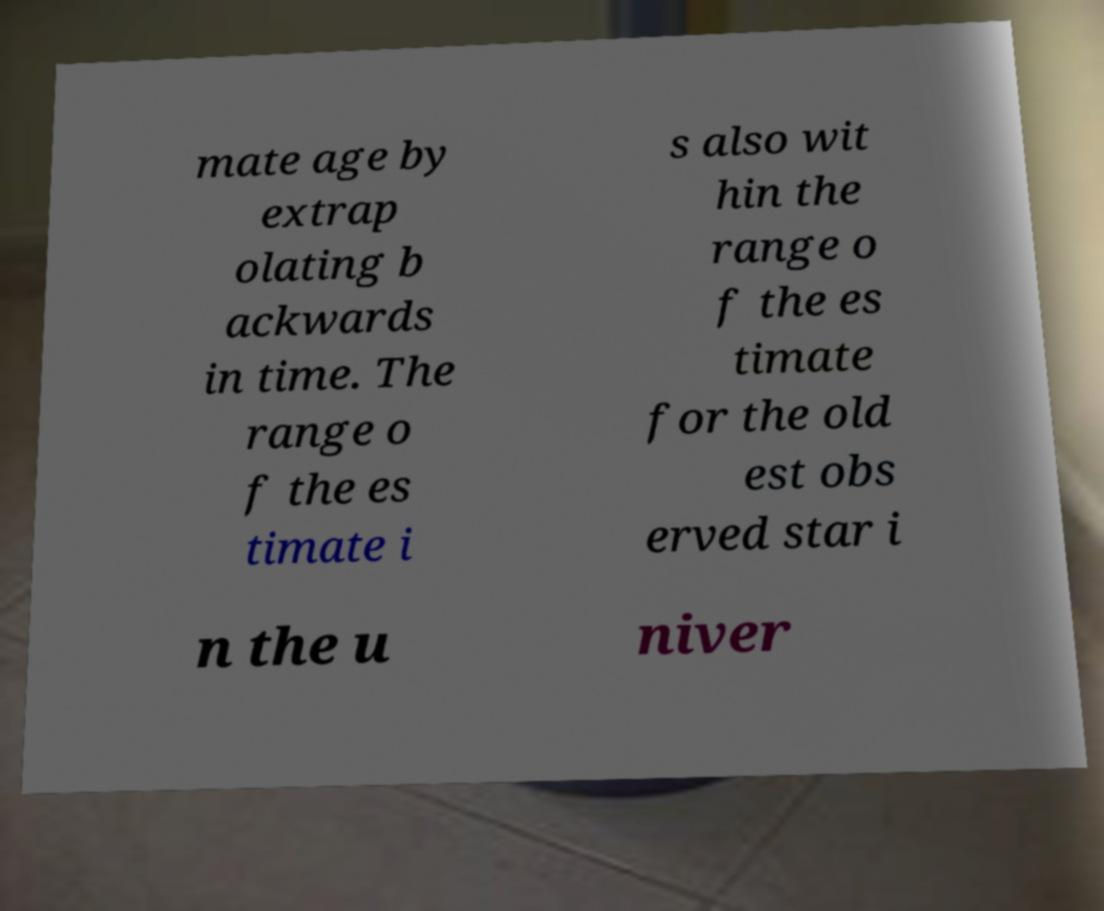Please read and relay the text visible in this image. What does it say? mate age by extrap olating b ackwards in time. The range o f the es timate i s also wit hin the range o f the es timate for the old est obs erved star i n the u niver 